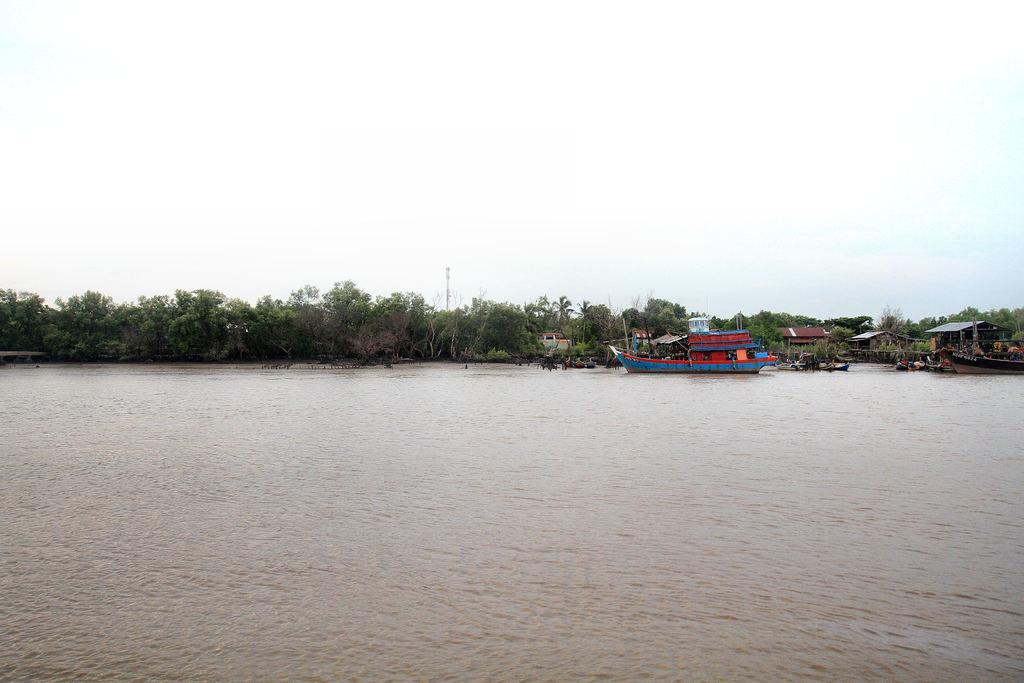What is the main subject in the center of the image? There is a boat in the water in the center of the image. What else can be seen in the image besides the boat? There is a group of buildings, trees, a pole, and the sky visible in the image. Can you describe the buildings in the image? The group of buildings in the image is not described in detail, but they are present. What is the background of the image? The background of the image includes a pole, trees, and the sky. What direction is the band playing in the image? There is no band present in the image, so it is not possible to determine the direction in which they might be playing. 